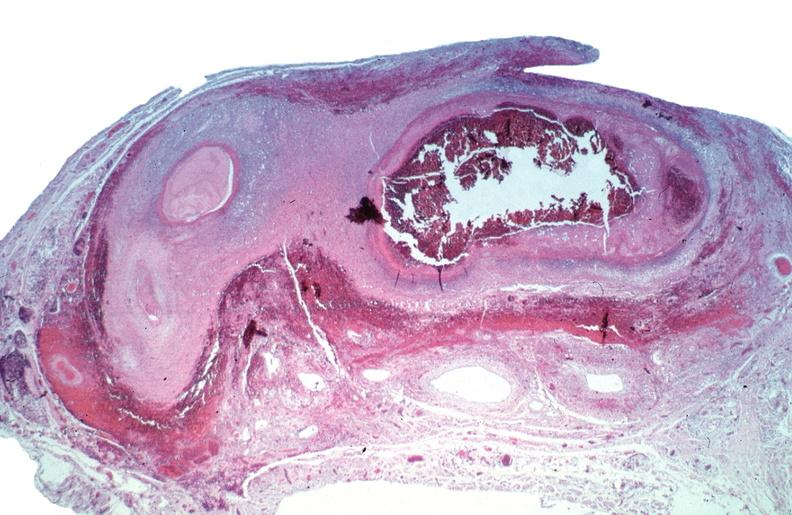s this present?
Answer the question using a single word or phrase. No 